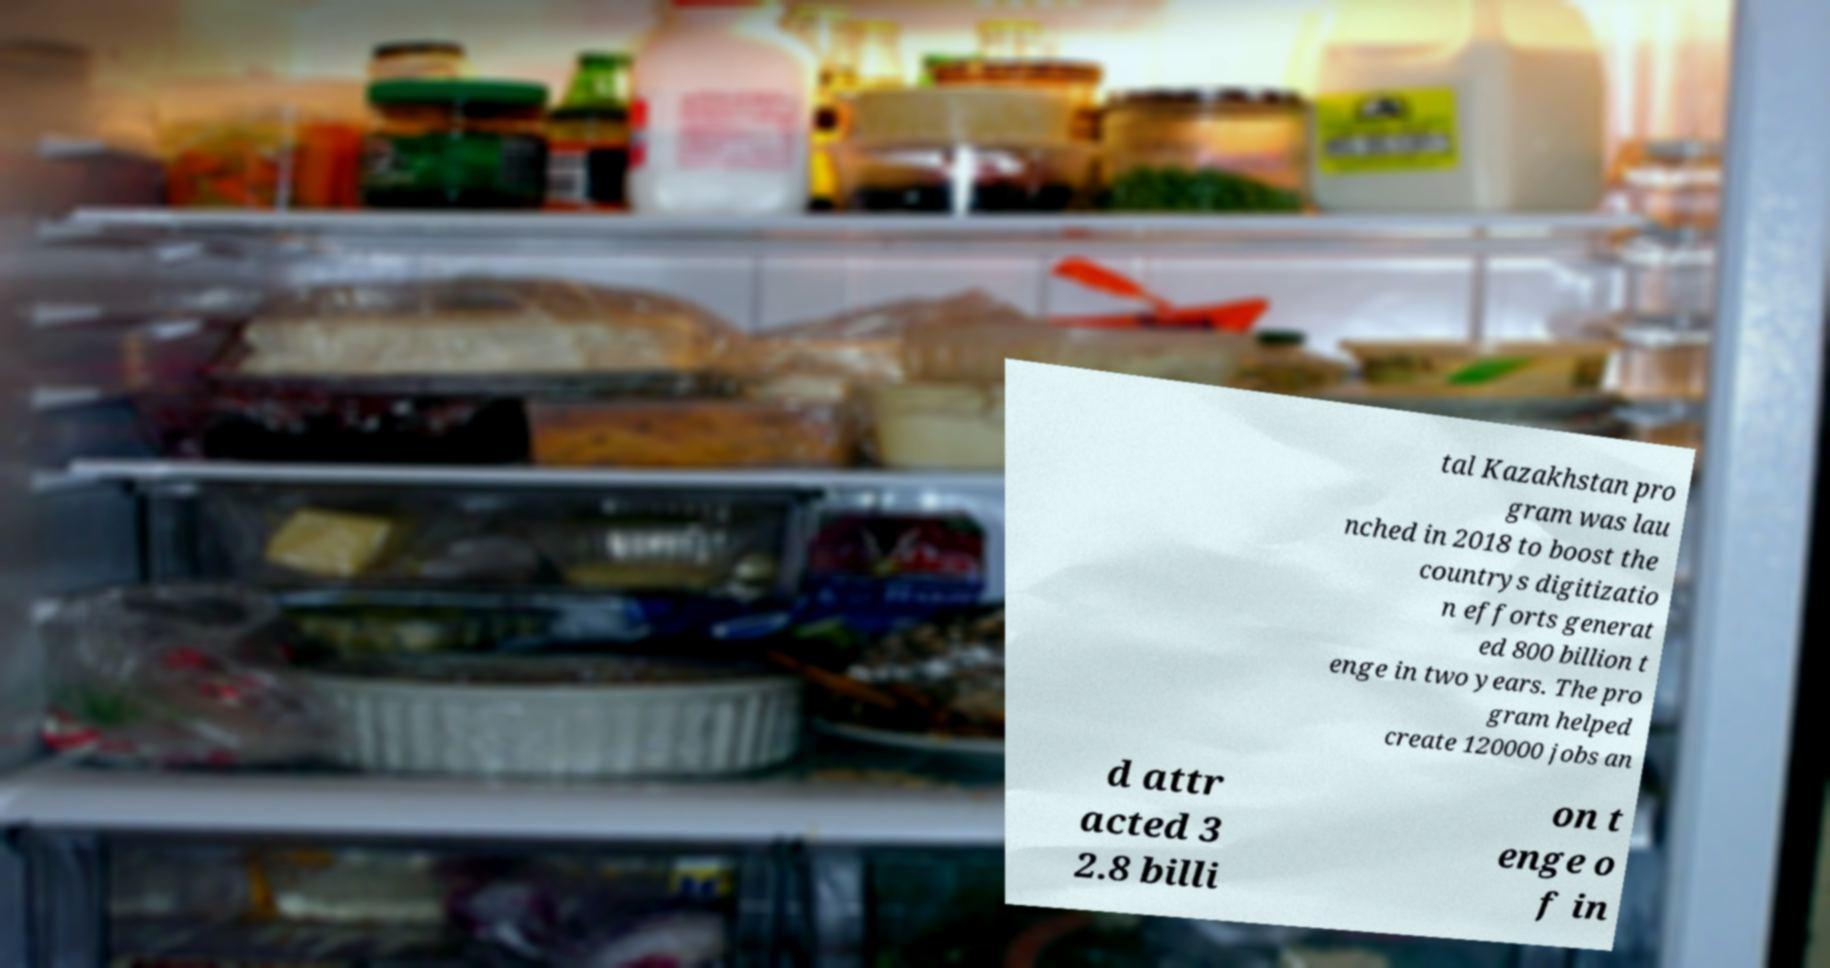There's text embedded in this image that I need extracted. Can you transcribe it verbatim? tal Kazakhstan pro gram was lau nched in 2018 to boost the countrys digitizatio n efforts generat ed 800 billion t enge in two years. The pro gram helped create 120000 jobs an d attr acted 3 2.8 billi on t enge o f in 